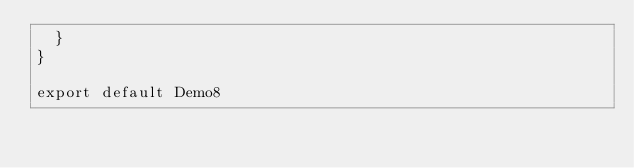<code> <loc_0><loc_0><loc_500><loc_500><_JavaScript_>  }
}

export default Demo8
</code> 